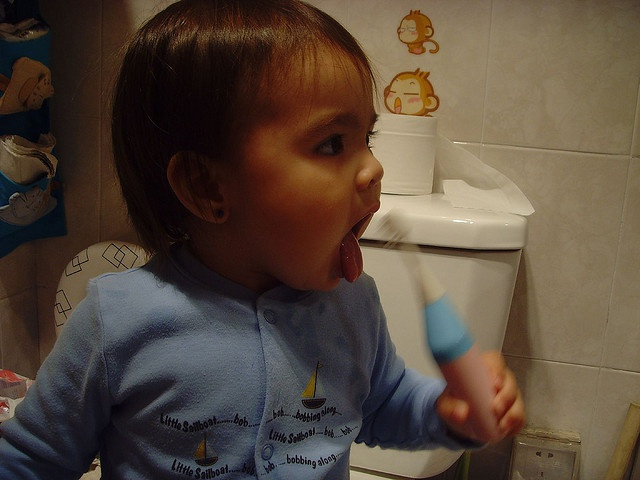Describe the objects in this image and their specific colors. I can see people in black, gray, and maroon tones, toilet in black, gray, and tan tones, and toothbrush in black, maroon, gray, and tan tones in this image. 